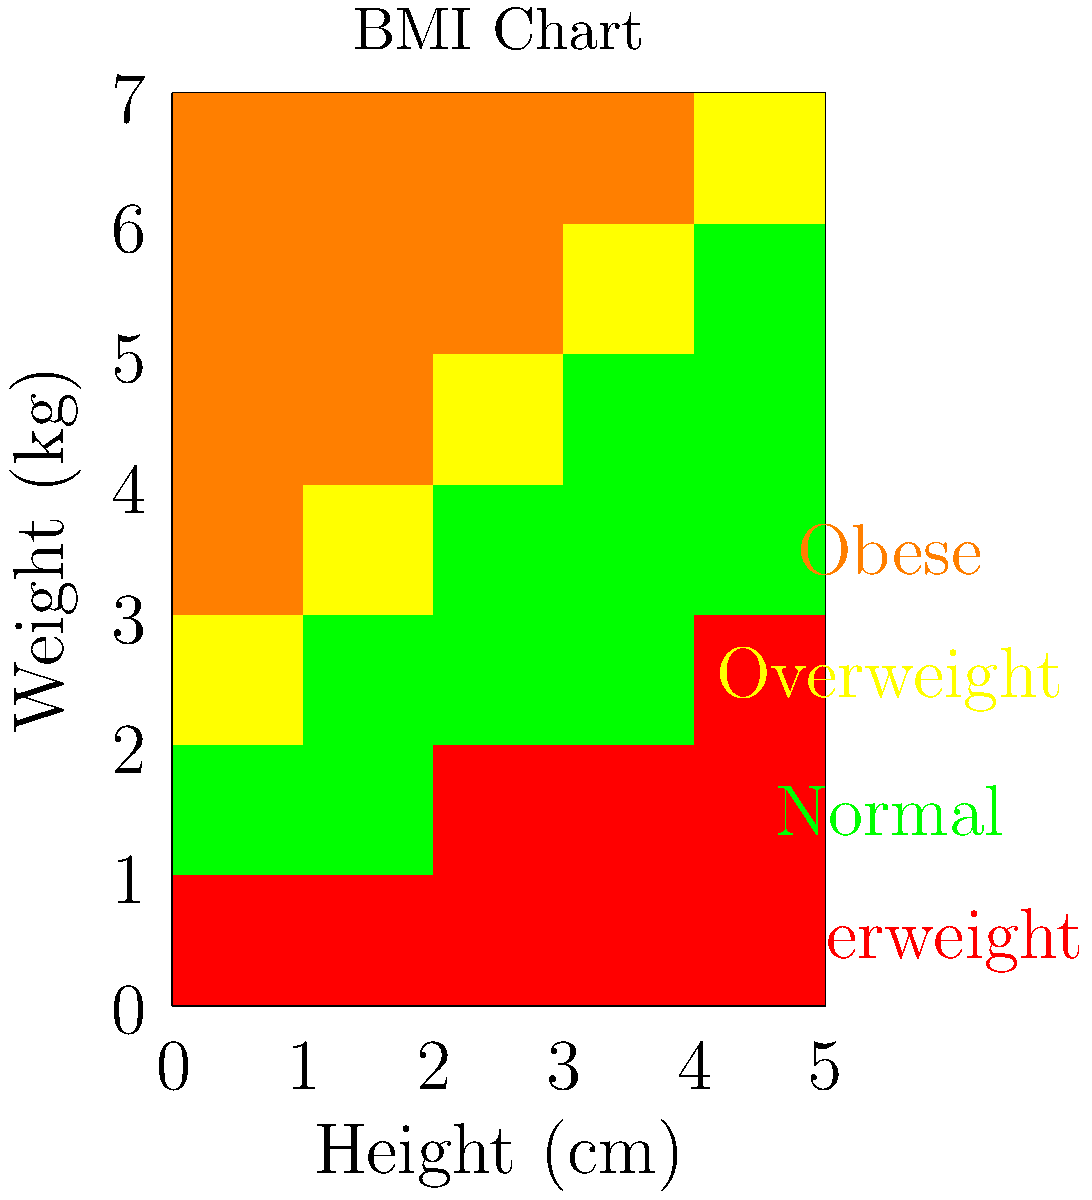Using the BMI chart provided, determine the BMI category for a person who is 170 cm tall and weighs 75 kg. How does this information relate to your fitness goals? To solve this problem, we'll follow these steps:

1. Locate the height of 170 cm on the x-axis of the chart.
2. Find the weight of 75 kg on the y-axis.
3. Identify the color of the box at the intersection of these values.
4. Match the color to the BMI category legend.

Following these steps:

1. 170 cm is the middle row on the x-axis.
2. 75 kg falls between 70 kg and 80 kg on the y-axis, closer to 70 kg.
3. The box at this intersection is yellow.
4. According to the legend, yellow corresponds to the "Overweight" category.

Therefore, a person who is 170 cm tall and weighs 75 kg falls into the "Overweight" BMI category.

For an aspiring fitness model, this information is crucial. BMI is a general indicator of body composition, though it doesn't account for muscle mass. As a fitness model, you might have a higher muscle mass, which could contribute to a higher BMI despite having a low body fat percentage. However, this BMI category suggests that you might want to focus on lean muscle building and fat loss to achieve a more ideal body composition for fitness modeling.

It's important to note that while BMI is a useful tool, it shouldn't be the only measure of fitness or health. Other factors such as body fat percentage, muscle mass, and overall physical performance are equally, if not more, important for a fitness model.
Answer: Overweight 